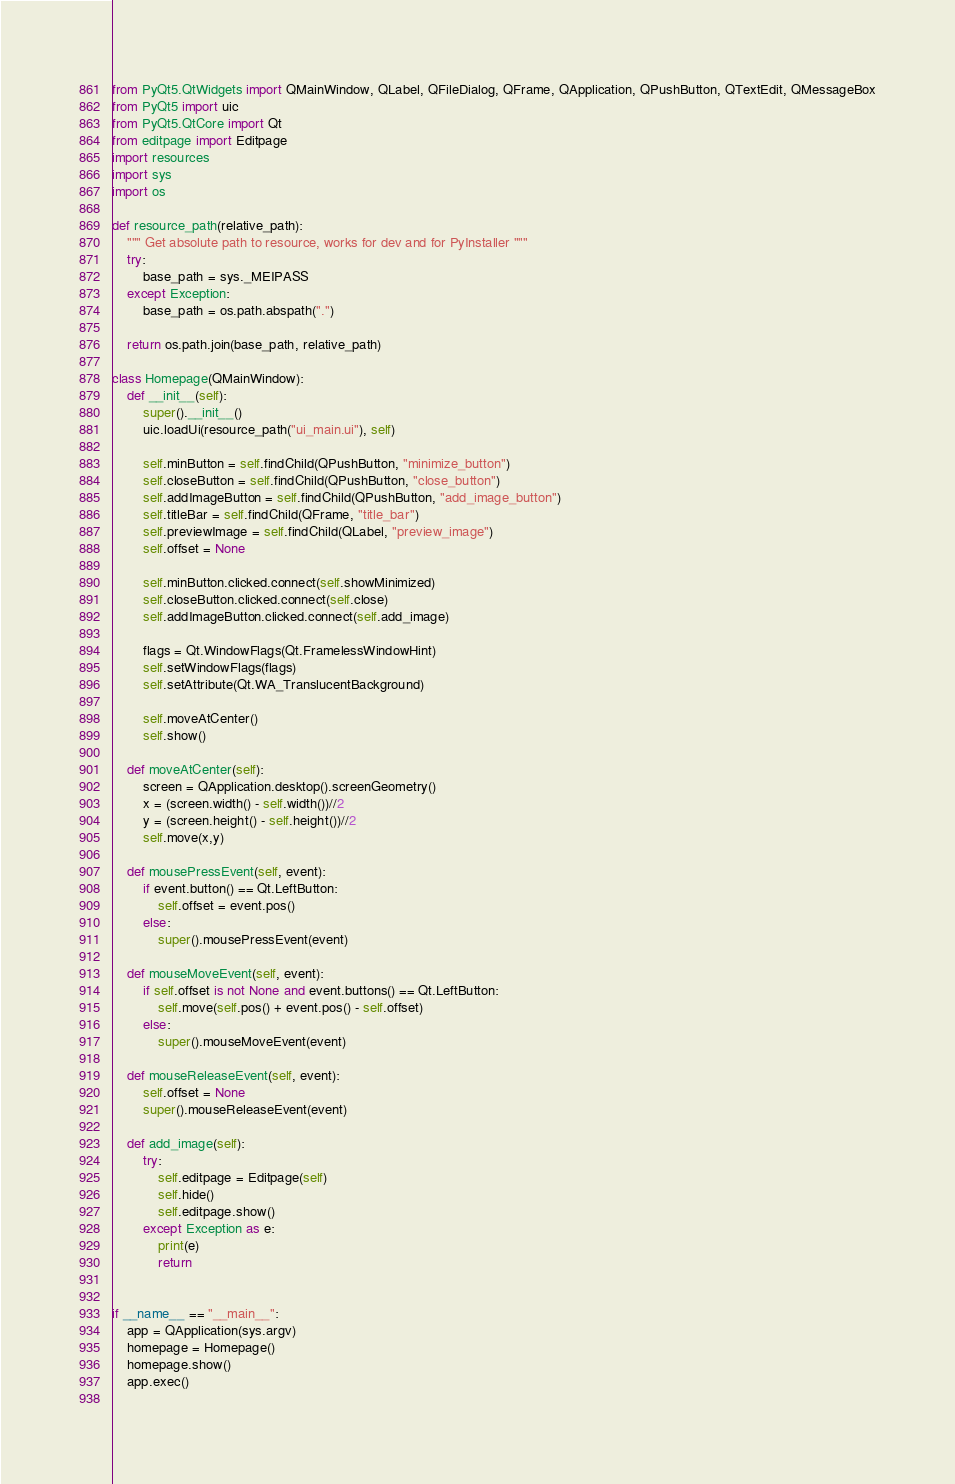<code> <loc_0><loc_0><loc_500><loc_500><_Python_>from PyQt5.QtWidgets import QMainWindow, QLabel, QFileDialog, QFrame, QApplication, QPushButton, QTextEdit, QMessageBox
from PyQt5 import uic
from PyQt5.QtCore import Qt
from editpage import Editpage
import resources
import sys
import os

def resource_path(relative_path):
    """ Get absolute path to resource, works for dev and for PyInstaller """
    try:
        base_path = sys._MEIPASS
    except Exception:
        base_path = os.path.abspath(".")

    return os.path.join(base_path, relative_path)

class Homepage(QMainWindow):
	def __init__(self):
		super().__init__()
		uic.loadUi(resource_path("ui_main.ui"), self)

		self.minButton = self.findChild(QPushButton, "minimize_button")
		self.closeButton = self.findChild(QPushButton, "close_button")
		self.addImageButton = self.findChild(QPushButton, "add_image_button")
		self.titleBar = self.findChild(QFrame, "title_bar")
		self.previewImage = self.findChild(QLabel, "preview_image")
		self.offset = None

		self.minButton.clicked.connect(self.showMinimized)
		self.closeButton.clicked.connect(self.close)
		self.addImageButton.clicked.connect(self.add_image)

		flags = Qt.WindowFlags(Qt.FramelessWindowHint)
		self.setWindowFlags(flags)
		self.setAttribute(Qt.WA_TranslucentBackground)

		self.moveAtCenter()
		self.show()

	def moveAtCenter(self):
		screen = QApplication.desktop().screenGeometry()
		x = (screen.width() - self.width())//2
		y = (screen.height() - self.height())//2
		self.move(x,y)		

	def mousePressEvent(self, event):
		if event.button() == Qt.LeftButton:
			self.offset = event.pos()
		else:
			super().mousePressEvent(event)

	def mouseMoveEvent(self, event):
		if self.offset is not None and event.buttons() == Qt.LeftButton:
			self.move(self.pos() + event.pos() - self.offset)
		else:
			super().mouseMoveEvent(event)

	def mouseReleaseEvent(self, event):
		self.offset = None
		super().mouseReleaseEvent(event)	

	def add_image(self):
		try:
			self.editpage = Editpage(self)
			self.hide()
			self.editpage.show()
		except Exception as e:
			print(e)
			return

	
if __name__ == "__main__":
    app = QApplication(sys.argv)
    homepage = Homepage()
    homepage.show()
    app.exec()
		

</code> 